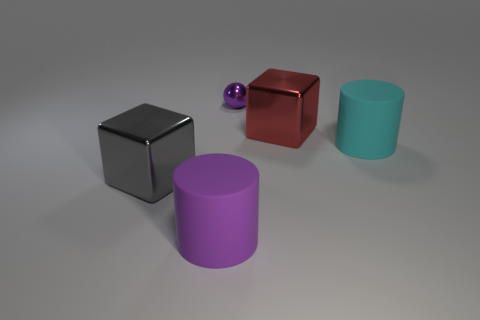Add 1 gray metal things. How many objects exist? 6 Subtract all cylinders. How many objects are left? 3 Subtract all gray objects. Subtract all green blocks. How many objects are left? 4 Add 2 small purple metallic objects. How many small purple metallic objects are left? 3 Add 2 large blue matte cubes. How many large blue matte cubes exist? 2 Subtract 0 gray spheres. How many objects are left? 5 